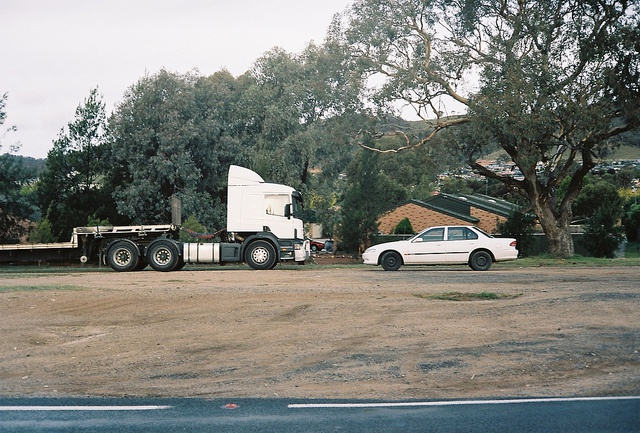Describe the objects in this image and their specific colors. I can see truck in lightgray, black, white, gray, and darkgray tones, car in lightgray, black, gray, and darkgray tones, and car in lightgray, black, maroon, gray, and darkgray tones in this image. 